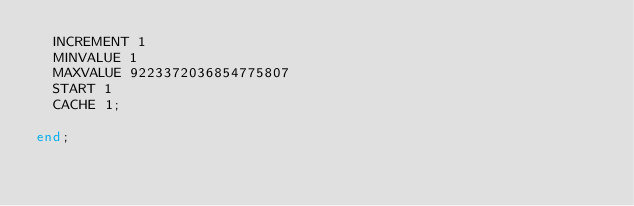<code> <loc_0><loc_0><loc_500><loc_500><_SQL_>  INCREMENT 1
  MINVALUE 1
  MAXVALUE 9223372036854775807
  START 1
  CACHE 1;

end;</code> 